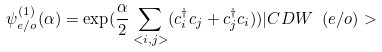Convert formula to latex. <formula><loc_0><loc_0><loc_500><loc_500>\psi _ { e / o } ^ { ( 1 ) } ( \alpha ) = \exp ( \frac { \alpha } { 2 } \sum _ { < i , j > } ( c _ { i } ^ { \dagger } c _ { j } + c _ { j } ^ { \dagger } c _ { i } ) ) | C D W \ ( e / o ) ></formula> 